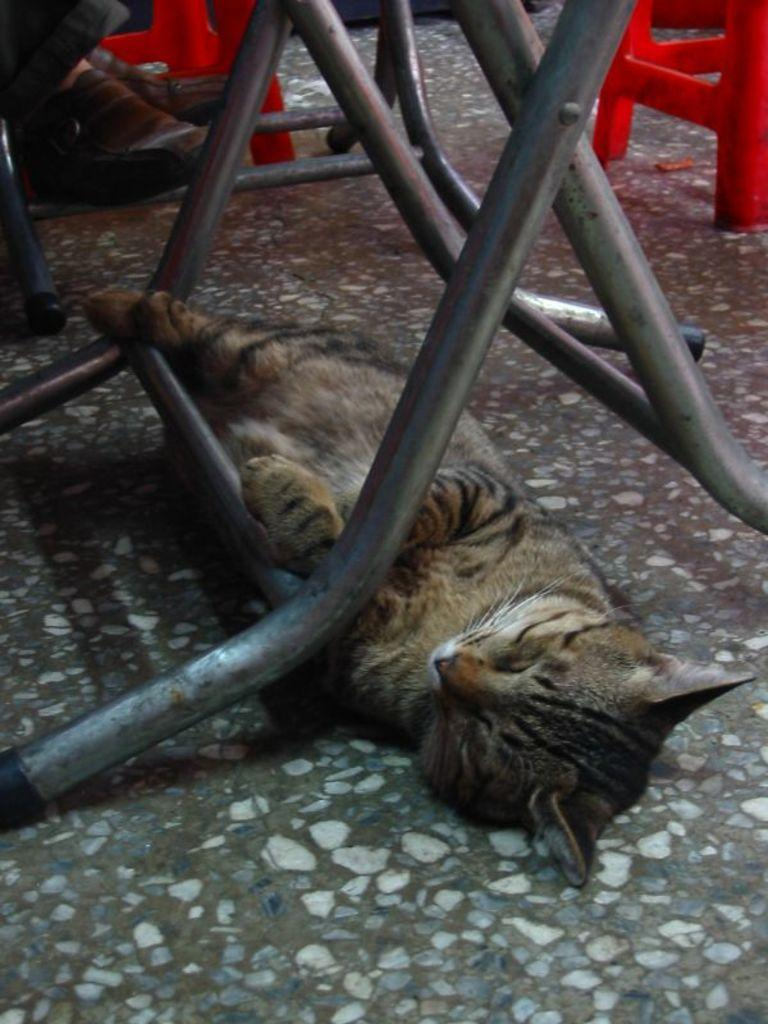What animal can be seen on the floor in the image? There is a cat on the floor in the image. What type of furniture is visible in the image? There are red color tables in the image. What part of a person is visible in the image? The legs of a person are present in the image. Are there any structural elements visible in the image? Yes, table rods are visible in the image. What type of arch can be seen in the image? There is no arch present in the image. What is being served for dinner in the image? The image does not show any dinner being served; it only shows a cat, red color tables, table rods, and the legs of a person. 